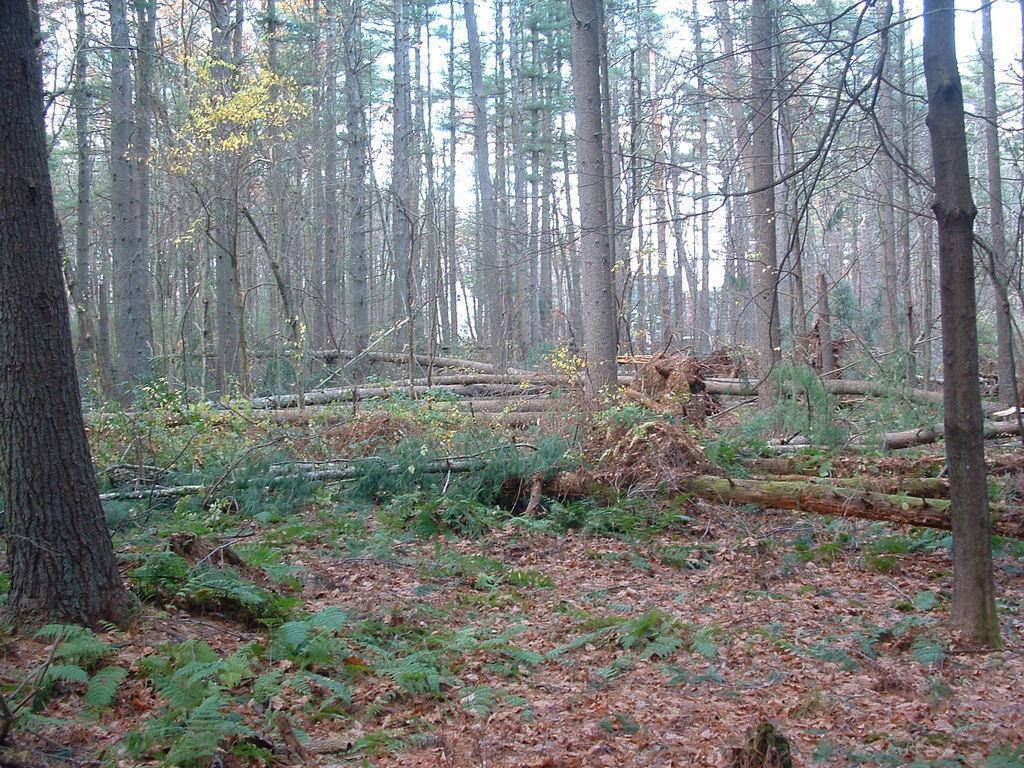Could you give a brief overview of what you see in this image? In this image we can see the trees, plants and also the dried leaves. Some part of the sky is also visible in this image. 